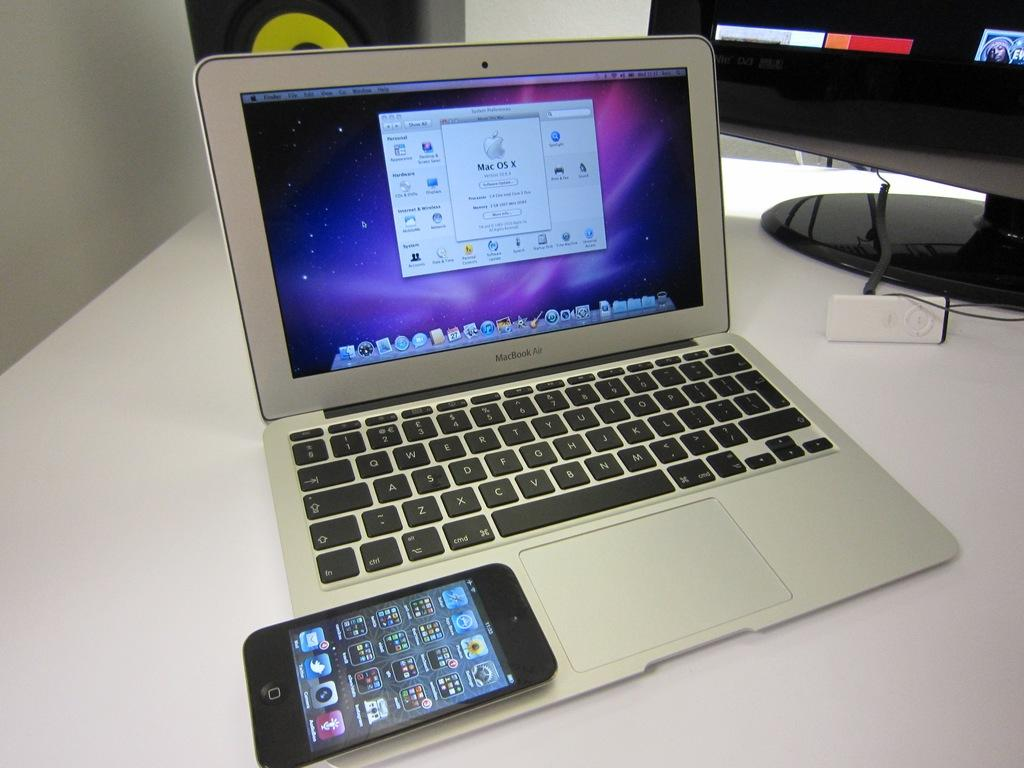<image>
Render a clear and concise summary of the photo. A MacBook Air sits open on a table with an iPhone resting next to the trackpad. 